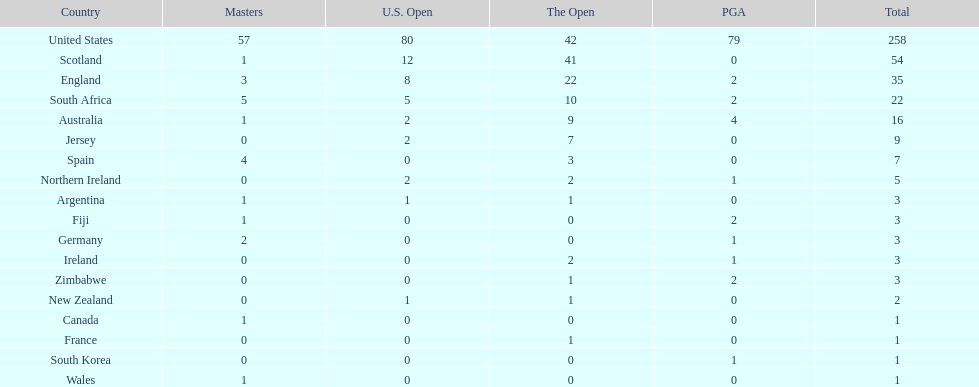I'm looking to parse the entire table for insights. Could you assist me with that? {'header': ['Country', 'Masters', 'U.S. Open', 'The Open', 'PGA', 'Total'], 'rows': [['United States', '57', '80', '42', '79', '258'], ['Scotland', '1', '12', '41', '0', '54'], ['England', '3', '8', '22', '2', '35'], ['South Africa', '5', '5', '10', '2', '22'], ['Australia', '1', '2', '9', '4', '16'], ['Jersey', '0', '2', '7', '0', '9'], ['Spain', '4', '0', '3', '0', '7'], ['Northern Ireland', '0', '2', '2', '1', '5'], ['Argentina', '1', '1', '1', '0', '3'], ['Fiji', '1', '0', '0', '2', '3'], ['Germany', '2', '0', '0', '1', '3'], ['Ireland', '0', '0', '2', '1', '3'], ['Zimbabwe', '0', '0', '1', '2', '3'], ['New Zealand', '0', '1', '1', '0', '2'], ['Canada', '1', '0', '0', '0', '1'], ['France', '0', '0', '1', '0', '1'], ['South Korea', '0', '0', '0', '1', '1'], ['Wales', '1', '0', '0', '0', '1']]} Together, how many victorious golfers do england and wales have in the masters? 4. 